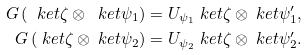Convert formula to latex. <formula><loc_0><loc_0><loc_500><loc_500>G \left ( \ k e t { \zeta } \otimes \ k e t { \psi _ { 1 } } \right ) & = U _ { \psi _ { 1 } } \ k e t { \zeta } \otimes \ k e t { \psi _ { 1 } ^ { \prime } } , \\ G \left ( \ k e t { \zeta } \otimes \ k e t { \psi _ { 2 } } \right ) & = U _ { \psi _ { 2 } } \ k e t { \zeta } \otimes \ k e t { \psi _ { 2 } ^ { \prime } } .</formula> 